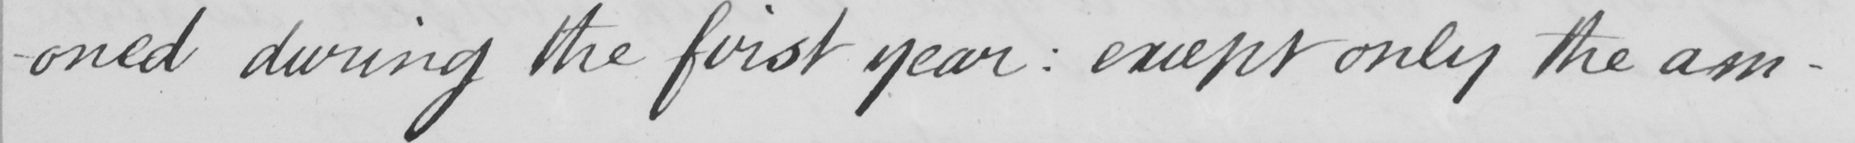What is written in this line of handwriting? -oned during the first year  :  except only the am- 